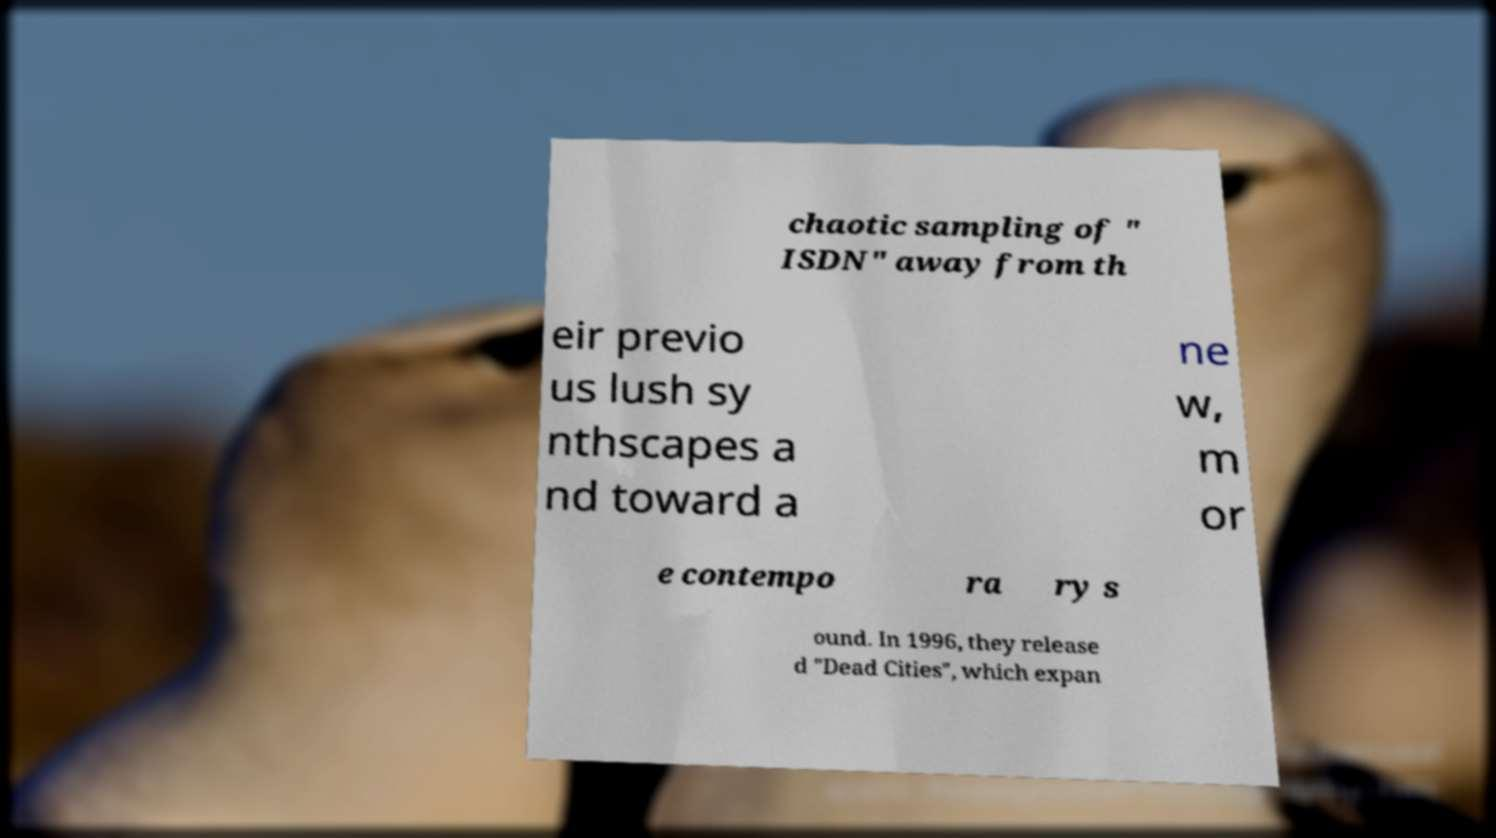Please identify and transcribe the text found in this image. chaotic sampling of " ISDN" away from th eir previo us lush sy nthscapes a nd toward a ne w, m or e contempo ra ry s ound. In 1996, they release d "Dead Cities", which expan 